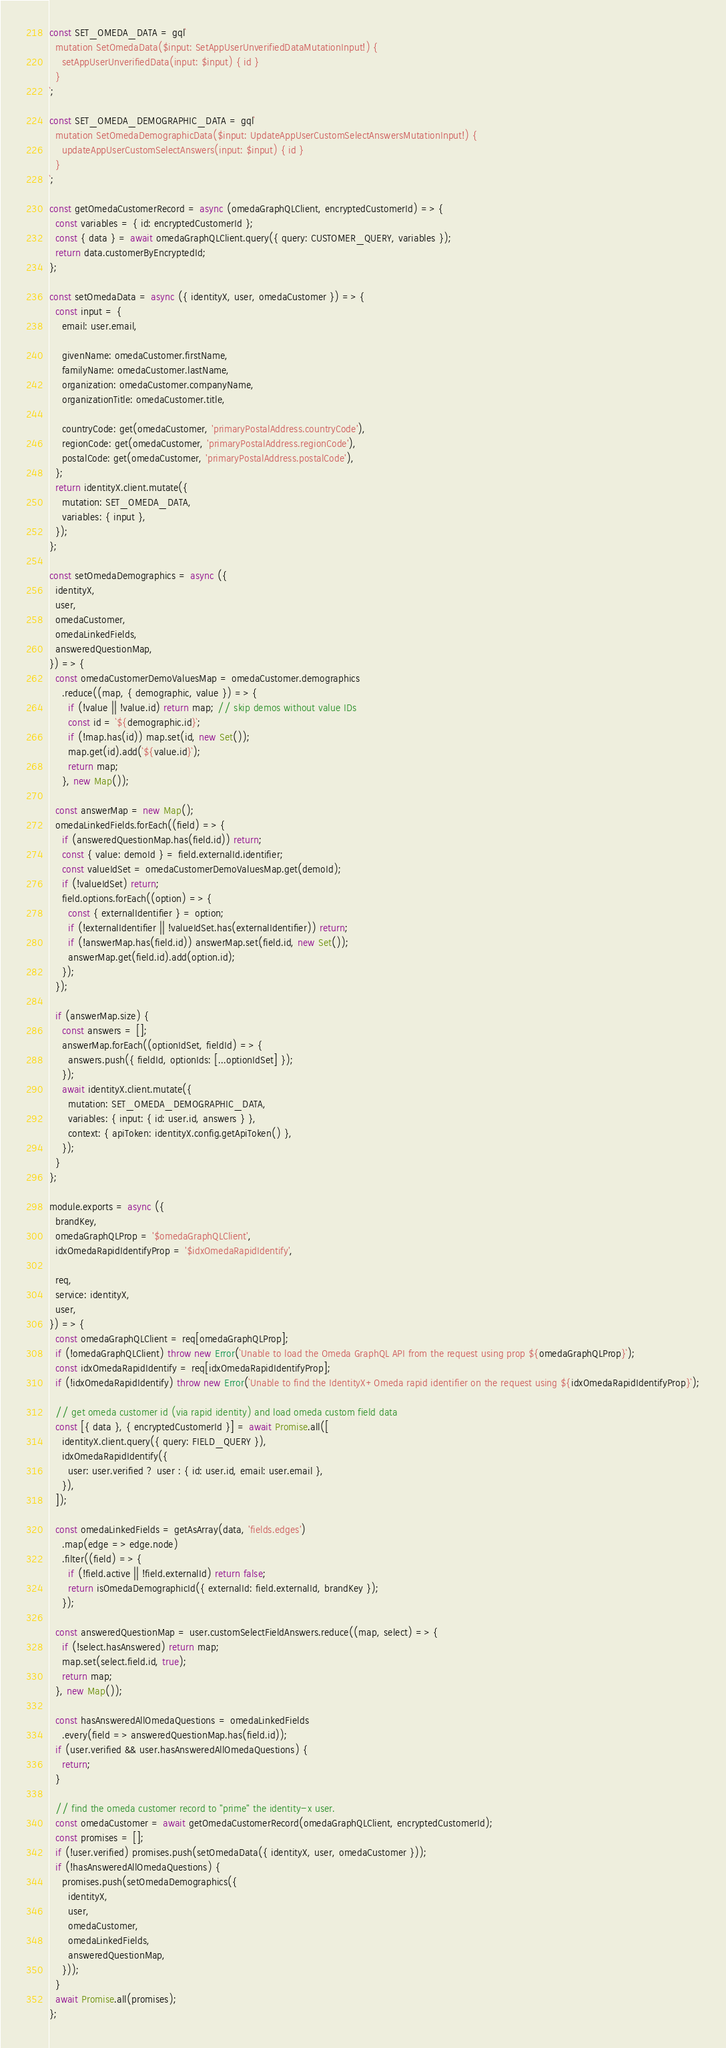Convert code to text. <code><loc_0><loc_0><loc_500><loc_500><_JavaScript_>const SET_OMEDA_DATA = gql`
  mutation SetOmedaData($input: SetAppUserUnverifiedDataMutationInput!) {
    setAppUserUnverifiedData(input: $input) { id }
  }
`;

const SET_OMEDA_DEMOGRAPHIC_DATA = gql`
  mutation SetOmedaDemographicData($input: UpdateAppUserCustomSelectAnswersMutationInput!) {
    updateAppUserCustomSelectAnswers(input: $input) { id }
  }
`;

const getOmedaCustomerRecord = async (omedaGraphQLClient, encryptedCustomerId) => {
  const variables = { id: encryptedCustomerId };
  const { data } = await omedaGraphQLClient.query({ query: CUSTOMER_QUERY, variables });
  return data.customerByEncryptedId;
};

const setOmedaData = async ({ identityX, user, omedaCustomer }) => {
  const input = {
    email: user.email,

    givenName: omedaCustomer.firstName,
    familyName: omedaCustomer.lastName,
    organization: omedaCustomer.companyName,
    organizationTitle: omedaCustomer.title,

    countryCode: get(omedaCustomer, 'primaryPostalAddress.countryCode'),
    regionCode: get(omedaCustomer, 'primaryPostalAddress.regionCode'),
    postalCode: get(omedaCustomer, 'primaryPostalAddress.postalCode'),
  };
  return identityX.client.mutate({
    mutation: SET_OMEDA_DATA,
    variables: { input },
  });
};

const setOmedaDemographics = async ({
  identityX,
  user,
  omedaCustomer,
  omedaLinkedFields,
  answeredQuestionMap,
}) => {
  const omedaCustomerDemoValuesMap = omedaCustomer.demographics
    .reduce((map, { demographic, value }) => {
      if (!value || !value.id) return map; // skip demos without value IDs
      const id = `${demographic.id}`;
      if (!map.has(id)) map.set(id, new Set());
      map.get(id).add(`${value.id}`);
      return map;
    }, new Map());

  const answerMap = new Map();
  omedaLinkedFields.forEach((field) => {
    if (answeredQuestionMap.has(field.id)) return;
    const { value: demoId } = field.externalId.identifier;
    const valueIdSet = omedaCustomerDemoValuesMap.get(demoId);
    if (!valueIdSet) return;
    field.options.forEach((option) => {
      const { externalIdentifier } = option;
      if (!externalIdentifier || !valueIdSet.has(externalIdentifier)) return;
      if (!answerMap.has(field.id)) answerMap.set(field.id, new Set());
      answerMap.get(field.id).add(option.id);
    });
  });

  if (answerMap.size) {
    const answers = [];
    answerMap.forEach((optionIdSet, fieldId) => {
      answers.push({ fieldId, optionIds: [...optionIdSet] });
    });
    await identityX.client.mutate({
      mutation: SET_OMEDA_DEMOGRAPHIC_DATA,
      variables: { input: { id: user.id, answers } },
      context: { apiToken: identityX.config.getApiToken() },
    });
  }
};

module.exports = async ({
  brandKey,
  omedaGraphQLProp = '$omedaGraphQLClient',
  idxOmedaRapidIdentifyProp = '$idxOmedaRapidIdentify',

  req,
  service: identityX,
  user,
}) => {
  const omedaGraphQLClient = req[omedaGraphQLProp];
  if (!omedaGraphQLClient) throw new Error(`Unable to load the Omeda GraphQL API from the request using prop ${omedaGraphQLProp}`);
  const idxOmedaRapidIdentify = req[idxOmedaRapidIdentifyProp];
  if (!idxOmedaRapidIdentify) throw new Error(`Unable to find the IdentityX+Omeda rapid identifier on the request using ${idxOmedaRapidIdentifyProp}`);

  // get omeda customer id (via rapid identity) and load omeda custom field data
  const [{ data }, { encryptedCustomerId }] = await Promise.all([
    identityX.client.query({ query: FIELD_QUERY }),
    idxOmedaRapidIdentify({
      user: user.verified ? user : { id: user.id, email: user.email },
    }),
  ]);

  const omedaLinkedFields = getAsArray(data, 'fields.edges')
    .map(edge => edge.node)
    .filter((field) => {
      if (!field.active || !field.externalId) return false;
      return isOmedaDemographicId({ externalId: field.externalId, brandKey });
    });

  const answeredQuestionMap = user.customSelectFieldAnswers.reduce((map, select) => {
    if (!select.hasAnswered) return map;
    map.set(select.field.id, true);
    return map;
  }, new Map());

  const hasAnsweredAllOmedaQuestions = omedaLinkedFields
    .every(field => answeredQuestionMap.has(field.id));
  if (user.verified && user.hasAnsweredAllOmedaQuestions) {
    return;
  }

  // find the omeda customer record to "prime" the identity-x user.
  const omedaCustomer = await getOmedaCustomerRecord(omedaGraphQLClient, encryptedCustomerId);
  const promises = [];
  if (!user.verified) promises.push(setOmedaData({ identityX, user, omedaCustomer }));
  if (!hasAnsweredAllOmedaQuestions) {
    promises.push(setOmedaDemographics({
      identityX,
      user,
      omedaCustomer,
      omedaLinkedFields,
      answeredQuestionMap,
    }));
  }
  await Promise.all(promises);
};
</code> 